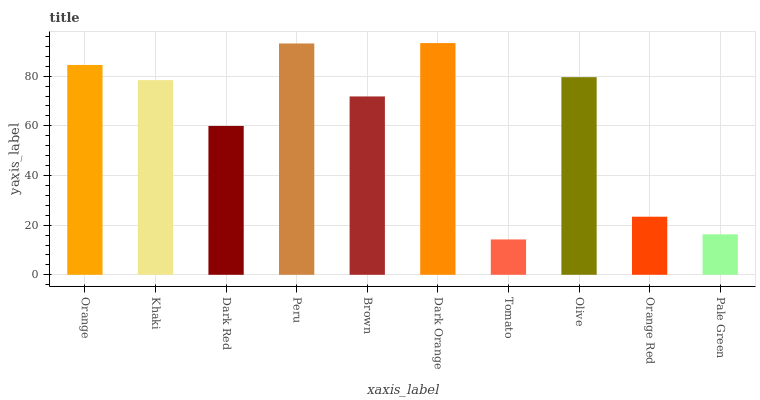Is Khaki the minimum?
Answer yes or no. No. Is Khaki the maximum?
Answer yes or no. No. Is Orange greater than Khaki?
Answer yes or no. Yes. Is Khaki less than Orange?
Answer yes or no. Yes. Is Khaki greater than Orange?
Answer yes or no. No. Is Orange less than Khaki?
Answer yes or no. No. Is Khaki the high median?
Answer yes or no. Yes. Is Brown the low median?
Answer yes or no. Yes. Is Dark Red the high median?
Answer yes or no. No. Is Khaki the low median?
Answer yes or no. No. 